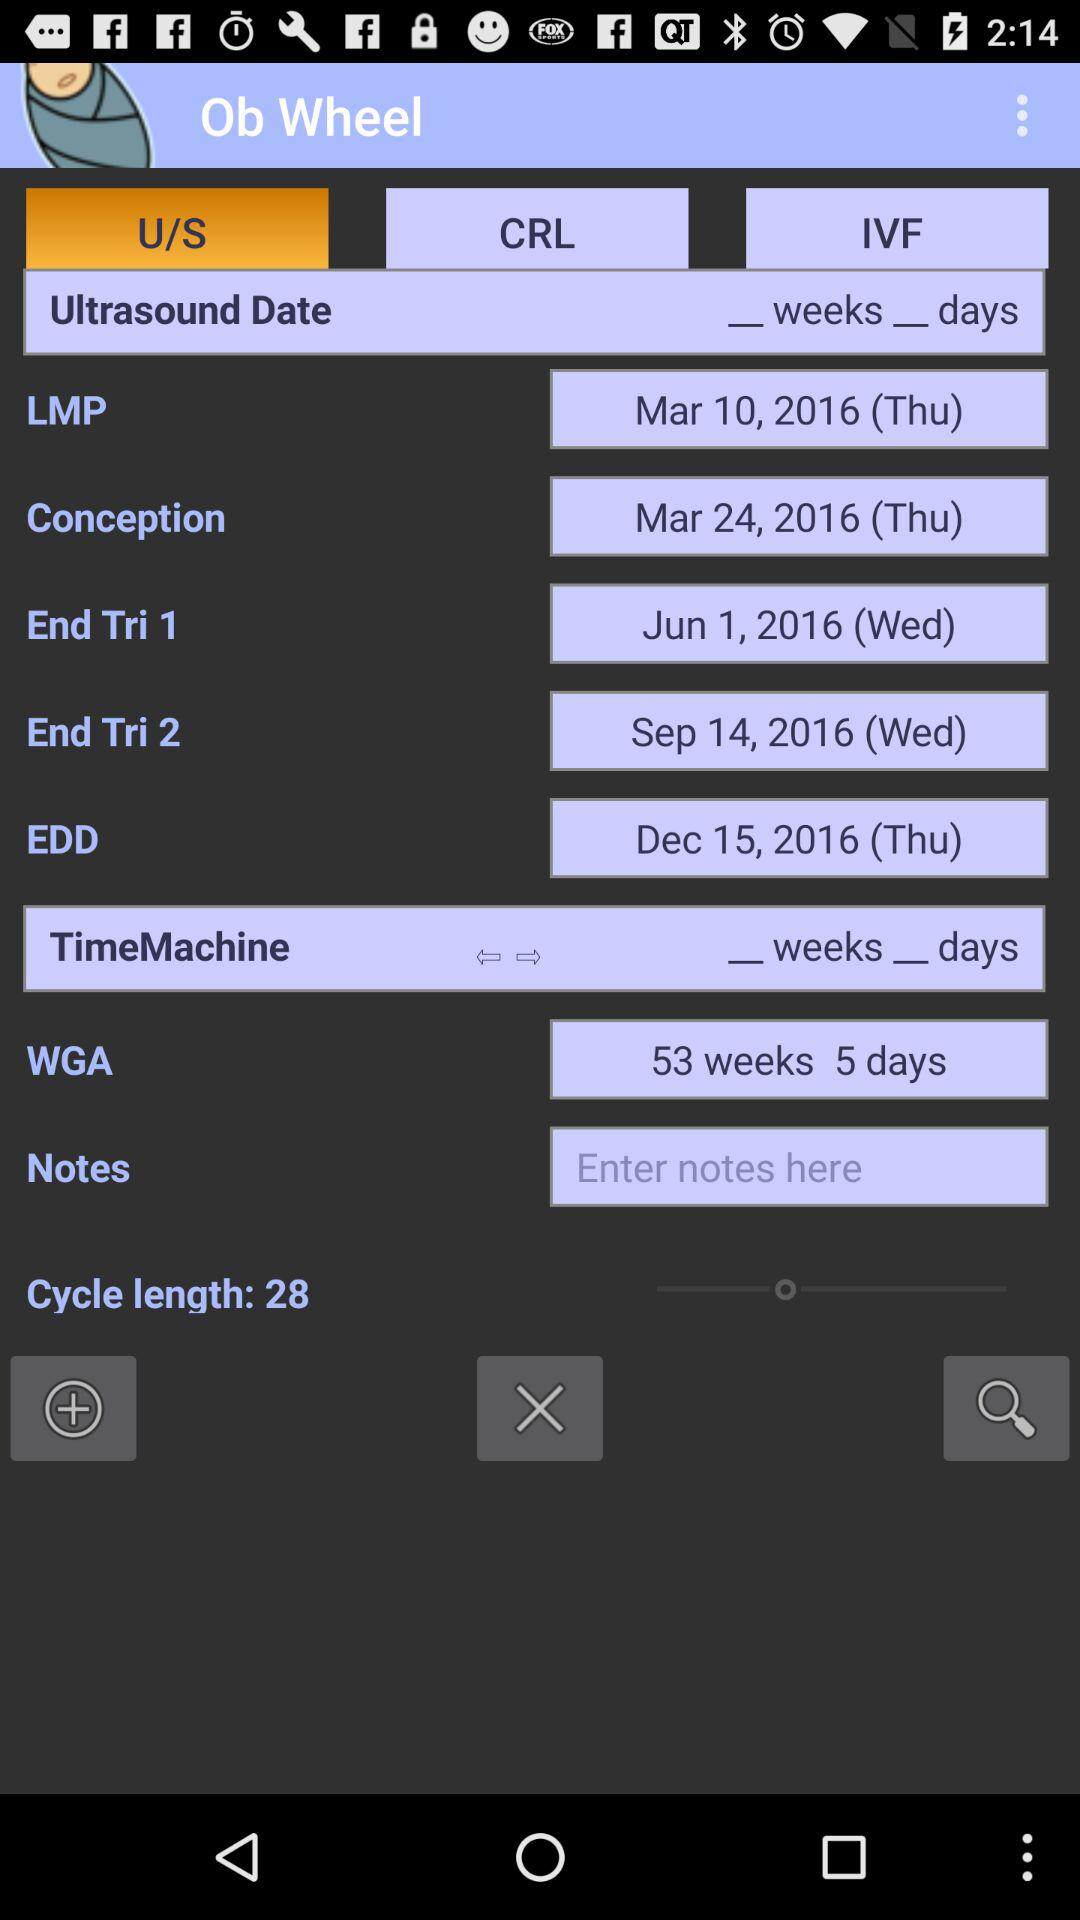What is the cycle length? The cycle length is 28. 